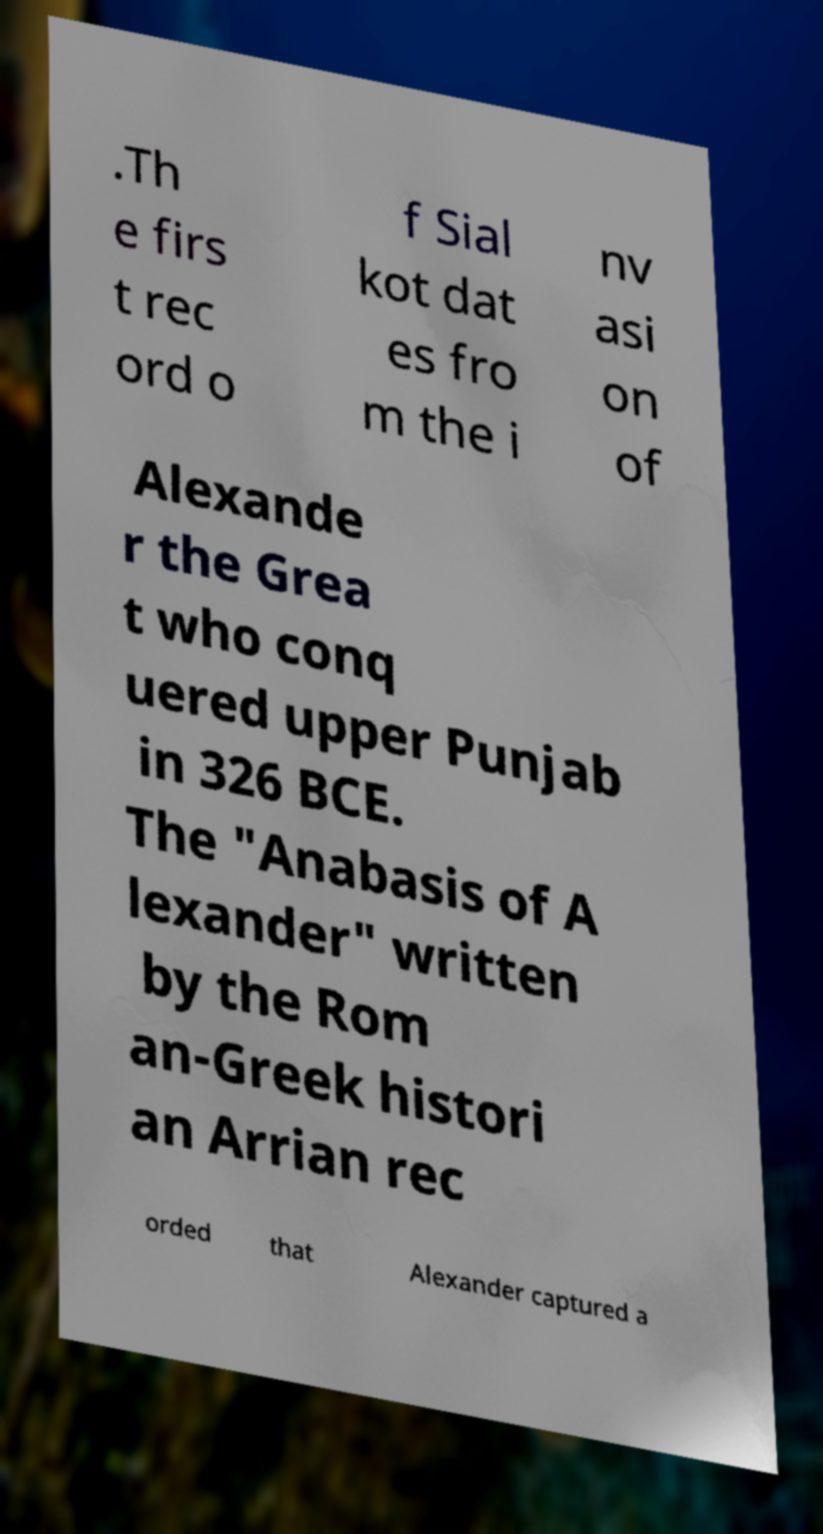I need the written content from this picture converted into text. Can you do that? .Th e firs t rec ord o f Sial kot dat es fro m the i nv asi on of Alexande r the Grea t who conq uered upper Punjab in 326 BCE. The "Anabasis of A lexander" written by the Rom an-Greek histori an Arrian rec orded that Alexander captured a 